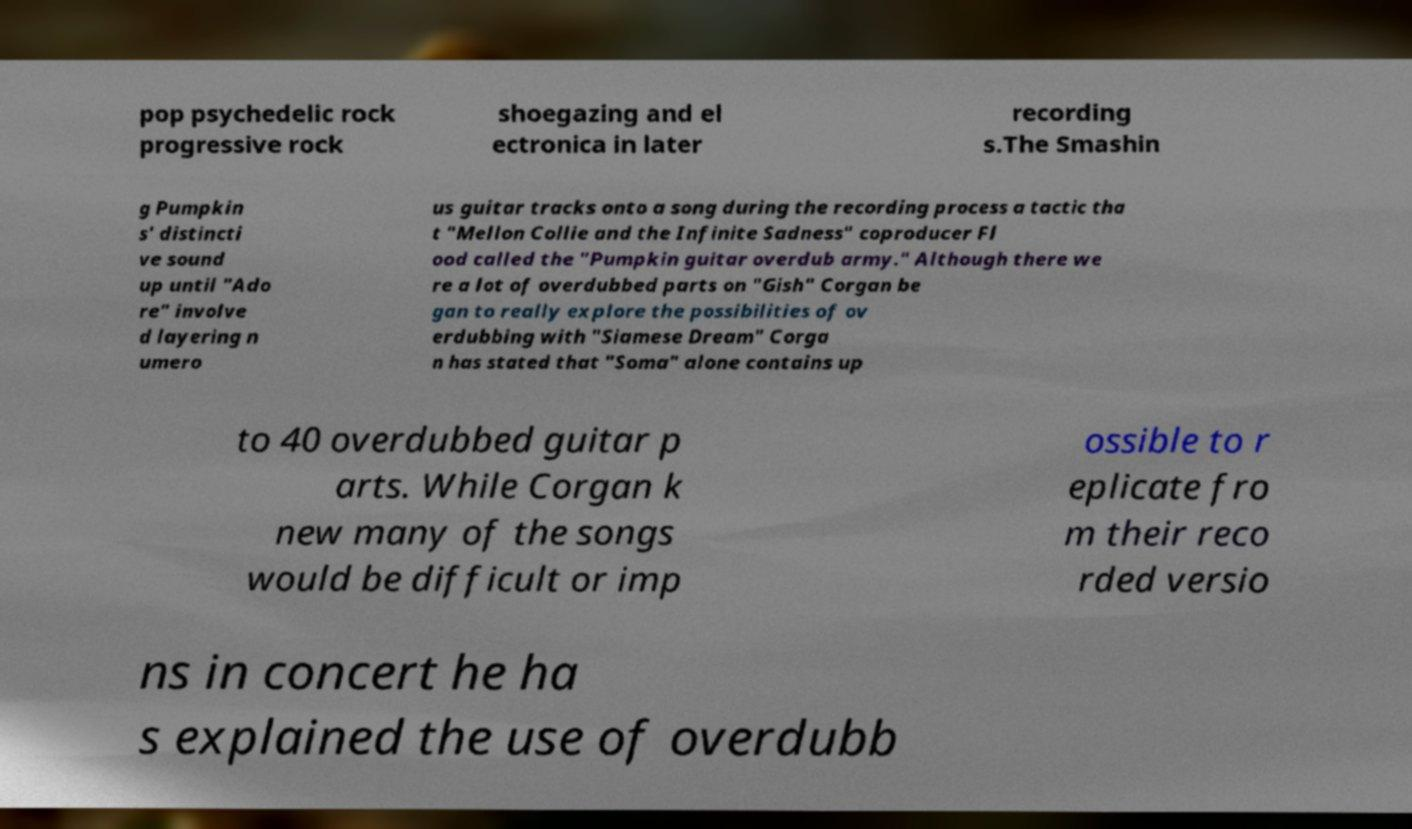For documentation purposes, I need the text within this image transcribed. Could you provide that? pop psychedelic rock progressive rock shoegazing and el ectronica in later recording s.The Smashin g Pumpkin s' distincti ve sound up until "Ado re" involve d layering n umero us guitar tracks onto a song during the recording process a tactic tha t "Mellon Collie and the Infinite Sadness" coproducer Fl ood called the "Pumpkin guitar overdub army." Although there we re a lot of overdubbed parts on "Gish" Corgan be gan to really explore the possibilities of ov erdubbing with "Siamese Dream" Corga n has stated that "Soma" alone contains up to 40 overdubbed guitar p arts. While Corgan k new many of the songs would be difficult or imp ossible to r eplicate fro m their reco rded versio ns in concert he ha s explained the use of overdubb 